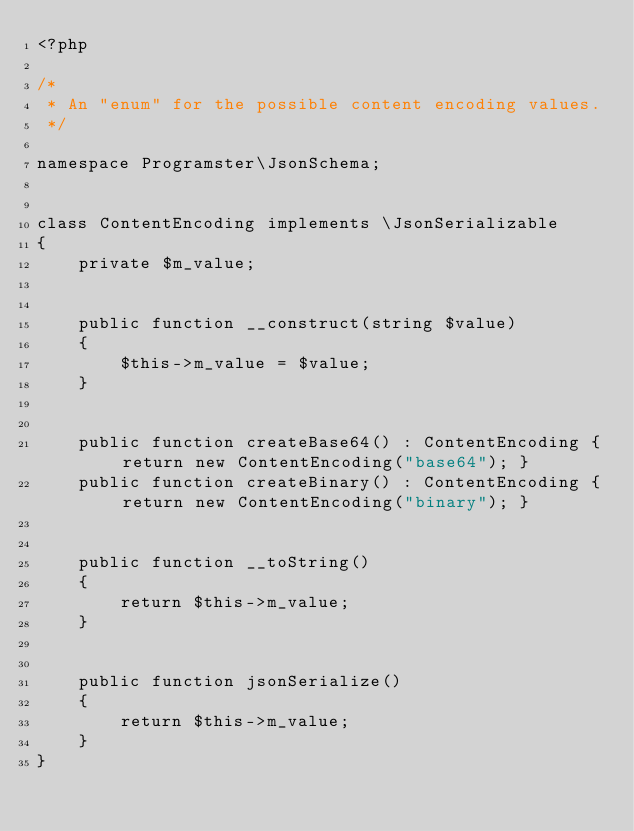Convert code to text. <code><loc_0><loc_0><loc_500><loc_500><_PHP_><?php

/*
 * An "enum" for the possible content encoding values.
 */

namespace Programster\JsonSchema;


class ContentEncoding implements \JsonSerializable
{
    private $m_value;


    public function __construct(string $value)
    {
        $this->m_value = $value;
    }


    public function createBase64() : ContentEncoding { return new ContentEncoding("base64"); }
    public function createBinary() : ContentEncoding { return new ContentEncoding("binary"); }


    public function __toString()
    {
        return $this->m_value;
    }


    public function jsonSerialize()
    {
        return $this->m_value;
    }
}</code> 